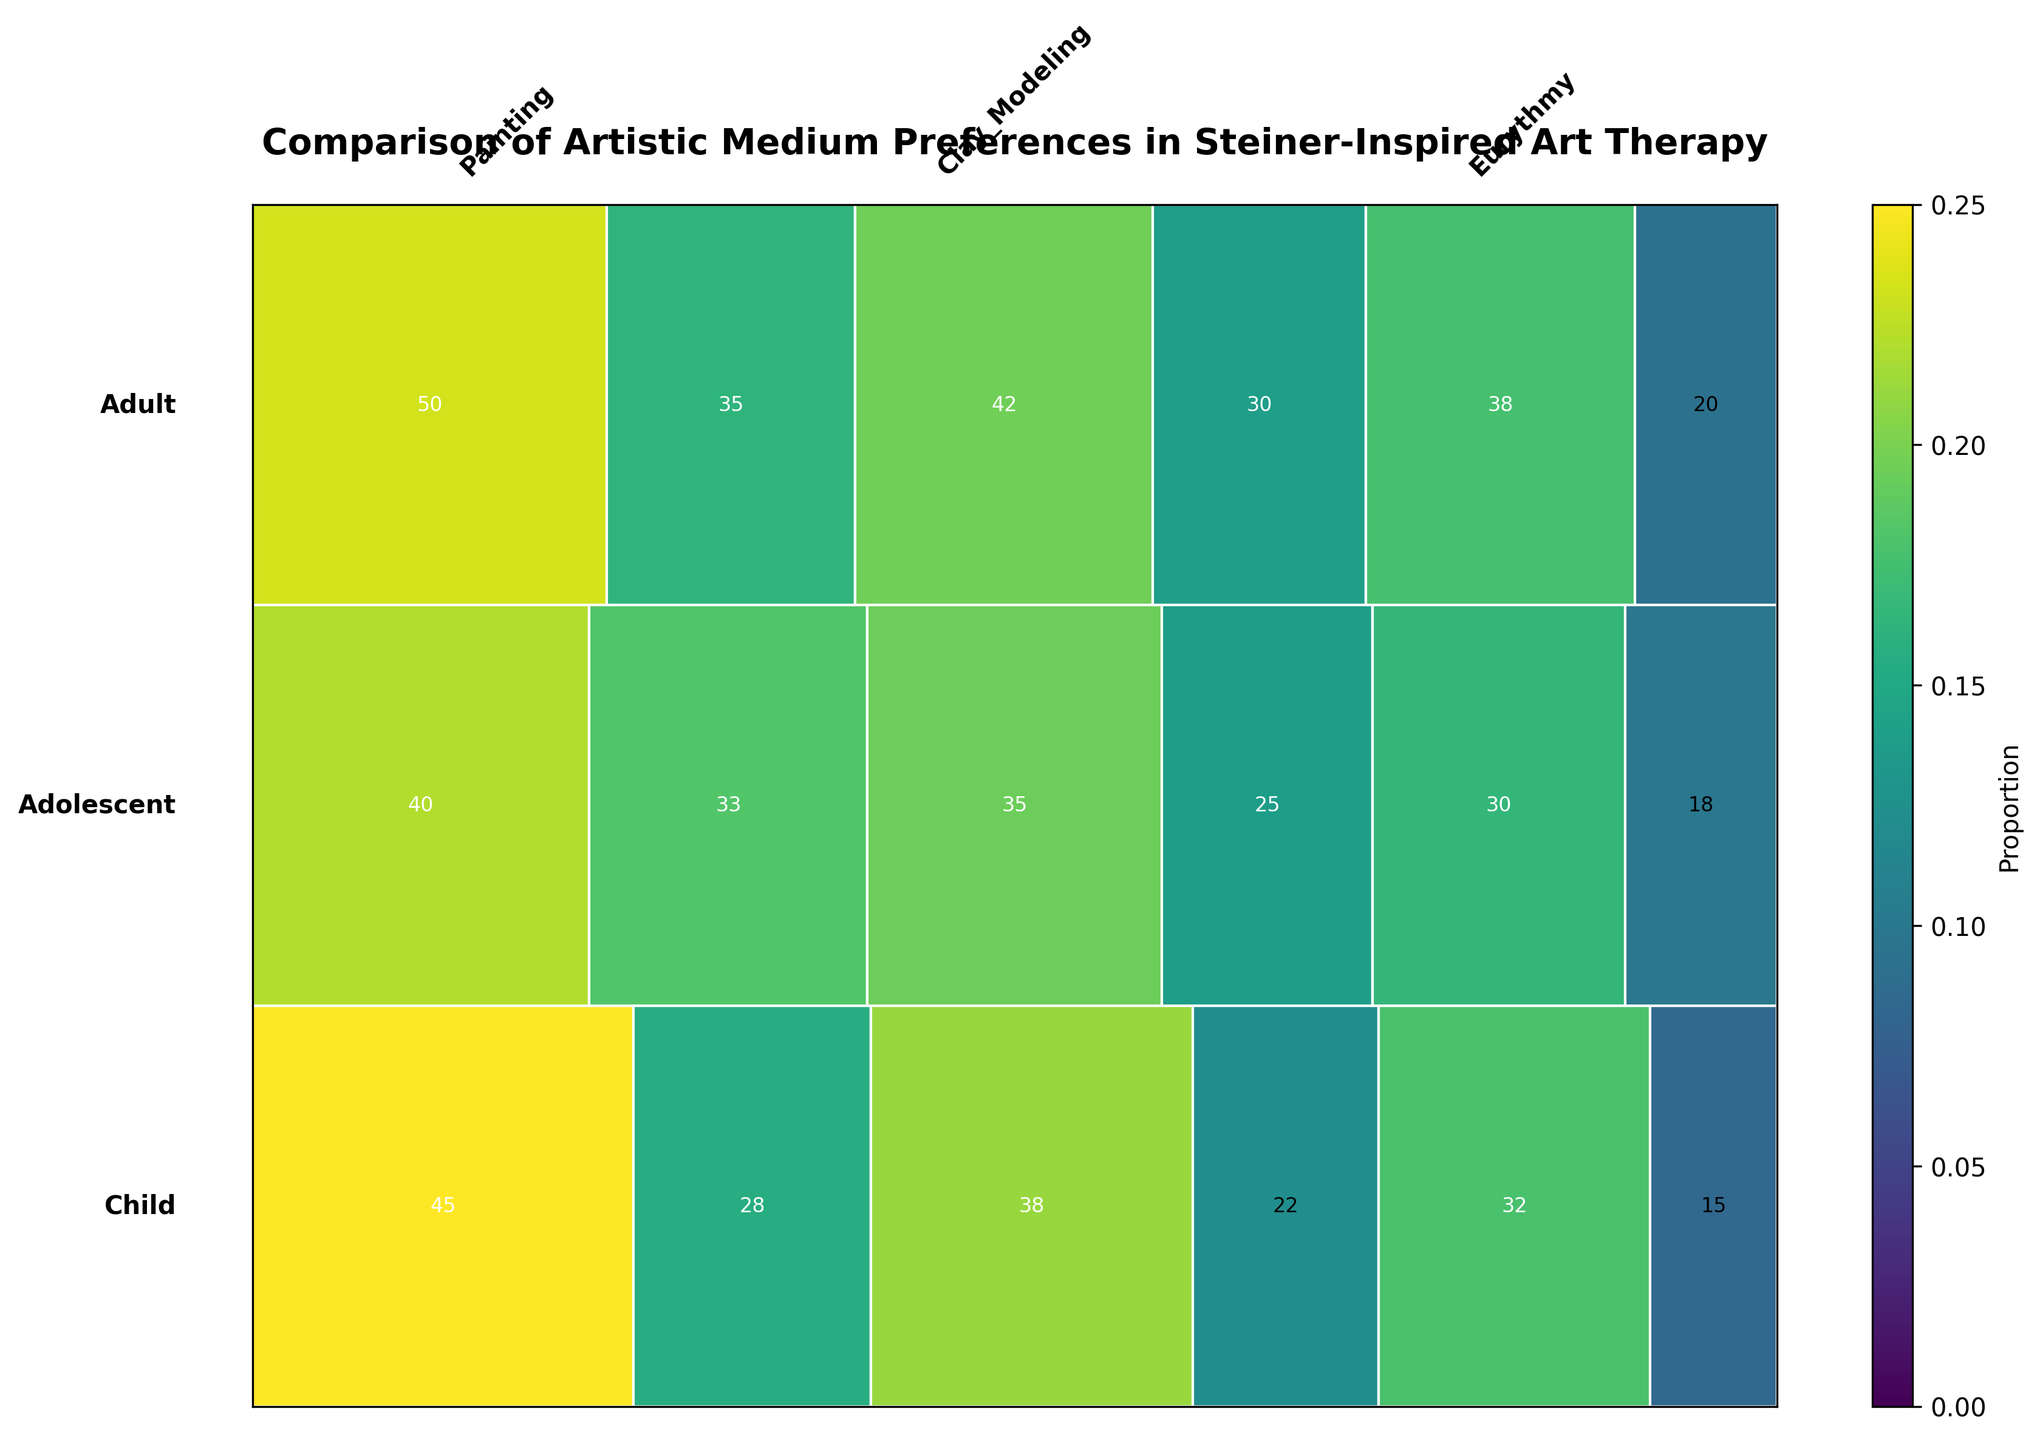What is the title of the mosaic plot? The title of the plot is usually found at the top of the figure. It briefly describes what is being depicted.
Answer: Comparison of Artistic Medium Preferences in Steiner-Inspired Art Therapy What age group is represented at the very bottom of the mosaic plot? The plot typically organizes age groups from top to bottom, so looking at the bottom-most section will reveal the age group.
Answer: Adult Which artistic medium is most preferred by children with Waldorf Education backgrounds? Find the section of the mosaic plot related to children with Waldorf Education backgrounds and identify the color or section representing the medium with the largest area.
Answer: Painting How does the preference for Eurythmy among adolescents with mainstream education compare to adults with non-Anthroposophical backgrounds? Locate the sections representing Eurythmy for adolescents with mainstream education and adults with non-Anthroposophical backgrounds; compare their proportions directly.
Answer: Adolescents with mainstream education prefer Eurythmy more Which client background shows the highest preference for clay modeling among adults? Look at the section of the plot corresponding to adults, then identify which background (Anthroposophical or Non-Anthroposophical) has the largest area for Clay Modeling.
Answer: Anthroposophical Background What proportion of Waldorf educated children prefer painting? This is a compositional question requiring the calculation of the proportion from the mosaic section corresponding to Waldorf educated children and painting.
Answer: 45 / (45 + 38 + 32) = 0.375 How does the total frequency of artistic medium preference for adolescents with Waldorf education compare to that of children with mainstream education? Calculate the total frequency for the specified groups by summing their respective counts and compare by subtraction or ratio.
Answer: Adolescents with Waldorf education have a higher total frequency What medium is least preferred by adults with an Anthroposophical background? Check each artistic medium section for adults with Anthroposophical backgrounds and find the one with the smallest area.
Answer: Eurythmy Which age group shows the highest overall frequency of preference for painting? Compare the total frequency counts for painting across all age groups by adding up sub-sections and identifying the highest.
Answer: Adult 